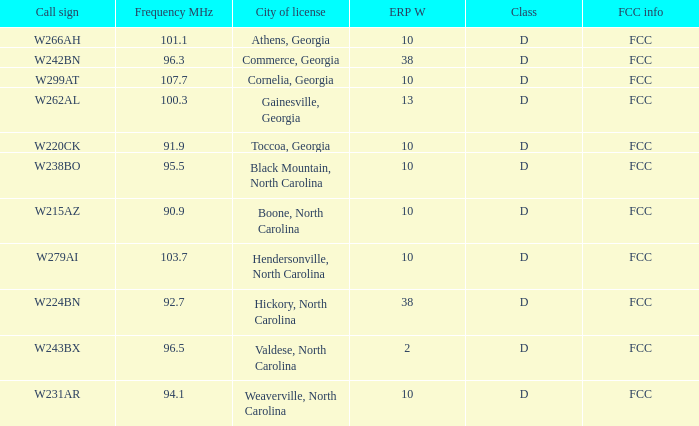When the frequency mhz of station w262al exceeds 92.7, what is its fcc frequency? FCC. Could you parse the entire table? {'header': ['Call sign', 'Frequency MHz', 'City of license', 'ERP W', 'Class', 'FCC info'], 'rows': [['W266AH', '101.1', 'Athens, Georgia', '10', 'D', 'FCC'], ['W242BN', '96.3', 'Commerce, Georgia', '38', 'D', 'FCC'], ['W299AT', '107.7', 'Cornelia, Georgia', '10', 'D', 'FCC'], ['W262AL', '100.3', 'Gainesville, Georgia', '13', 'D', 'FCC'], ['W220CK', '91.9', 'Toccoa, Georgia', '10', 'D', 'FCC'], ['W238BO', '95.5', 'Black Mountain, North Carolina', '10', 'D', 'FCC'], ['W215AZ', '90.9', 'Boone, North Carolina', '10', 'D', 'FCC'], ['W279AI', '103.7', 'Hendersonville, North Carolina', '10', 'D', 'FCC'], ['W224BN', '92.7', 'Hickory, North Carolina', '38', 'D', 'FCC'], ['W243BX', '96.5', 'Valdese, North Carolina', '2', 'D', 'FCC'], ['W231AR', '94.1', 'Weaverville, North Carolina', '10', 'D', 'FCC']]} 